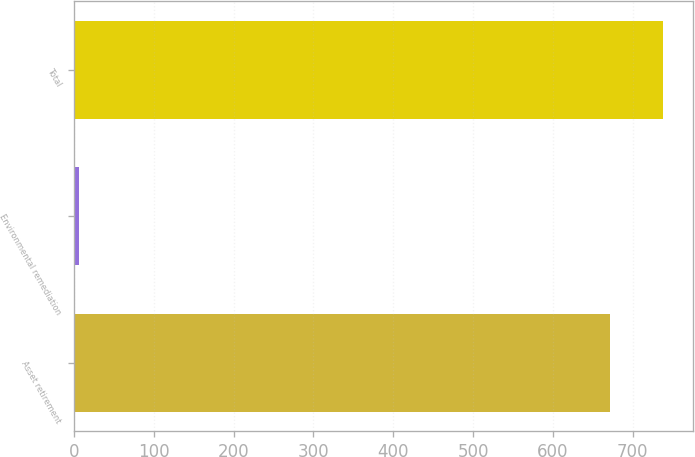Convert chart to OTSL. <chart><loc_0><loc_0><loc_500><loc_500><bar_chart><fcel>Asset retirement<fcel>Environmental remediation<fcel>Total<nl><fcel>671<fcel>6.7<fcel>738.1<nl></chart> 